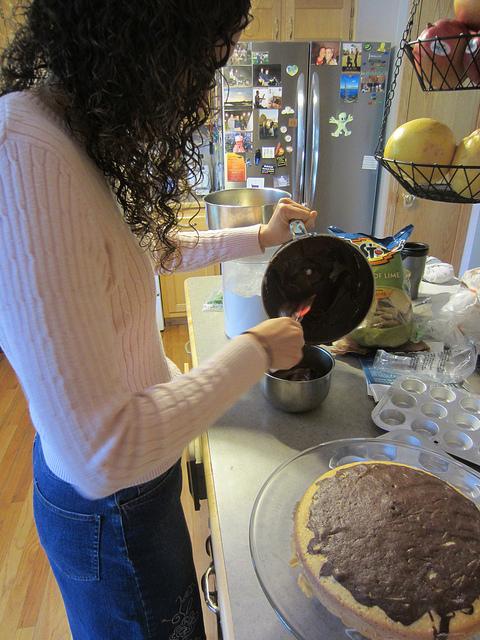What room is this person in?
Concise answer only. Kitchen. What is she baking?
Write a very short answer. Cake. What is the lady doing?
Concise answer only. Cooking. 